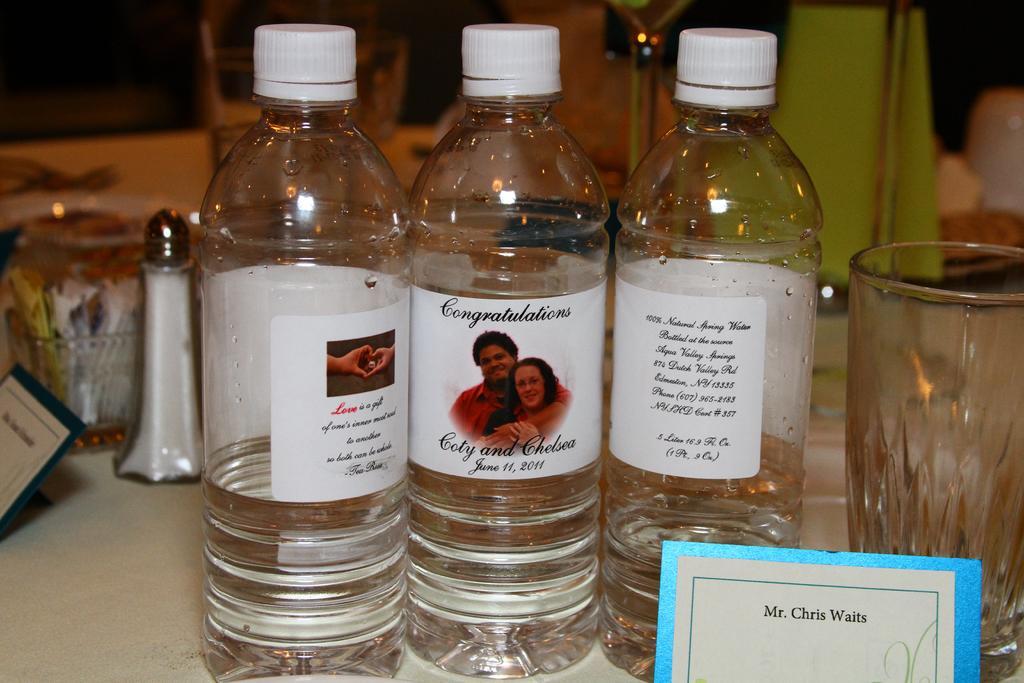How would you summarize this image in a sentence or two? in the given image we can see three bottle. These is a name written on a paper. This is a glass. 